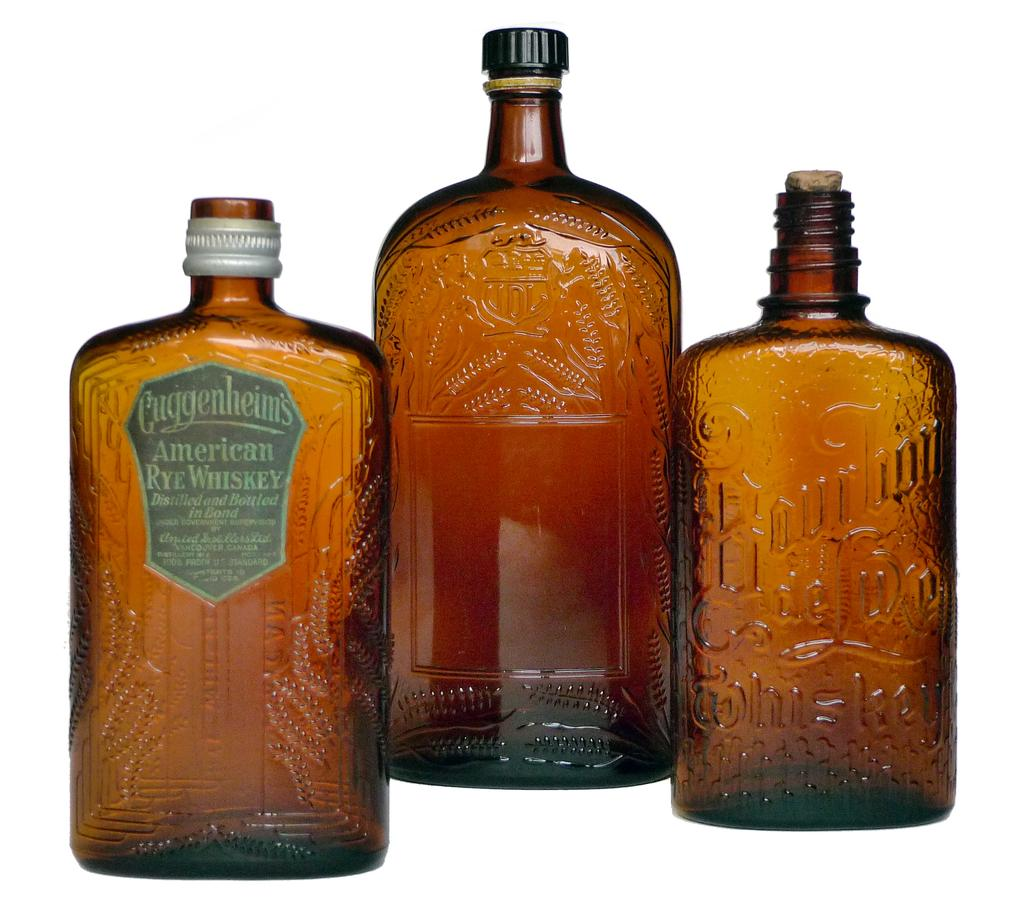<image>
Present a compact description of the photo's key features. 3 bottles of whiskey and one of them is from Cuggenheim. 